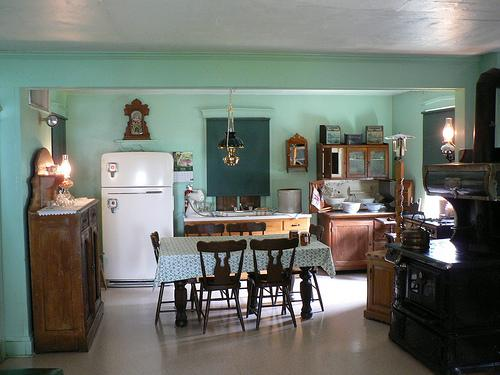Count the number of white bowls in the image and mention their placement. There are two white bowls, one on a cherry wood counter and the other on a shelf. Explain the appearance of the table cloth and the surface it is placed on. The table cloth is white with a design involving blue dots and is placed on a dining table. How many light fixtures are hanging from the ceiling and what are their types? There are two light fixtures hanging from the ceiling, one is a lantern and the other is a gold and black chandelier. What type of table is shown in the image and how many chairs are associated with it? A small dining room table with six wooden chairs is shown in the image. In the context of this image, what is unique about the stove and the items connected to it? The stove is an old fashioned black wood burning stove with a pipe connected to it, and it has a teakettle and a kerosene lantern on top. What type of floor does the kitchen have and what is its color? The kitchen has a white linoleum floor. List the items that can be found on top of the large black stove. A teakettle and a kerosene lantern can be found on top of the large black stove. Describe the refrigerator in the image, including its color and any other noteworthy features. The refrigerator is white, with features including being an old model and having a calendar next to it. What are the main objects placed on the sideboard, and describe them briefly? The main objects on the sideboard are white bowls, which are part of a kitchen setup. Can you identify the color of the window shade and the wall in the picture? The window shade is green and the walls are light blue painted. 